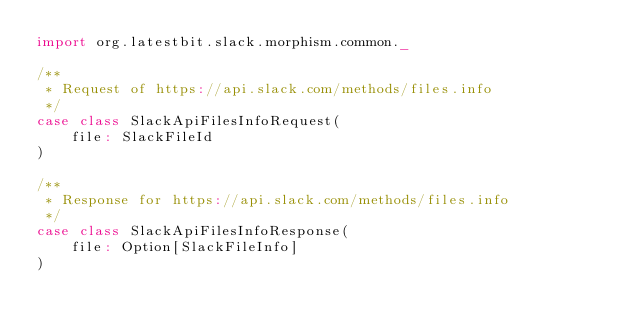<code> <loc_0><loc_0><loc_500><loc_500><_Scala_>import org.latestbit.slack.morphism.common._

/**
 * Request of https://api.slack.com/methods/files.info
 */
case class SlackApiFilesInfoRequest(
    file: SlackFileId
)

/**
 * Response for https://api.slack.com/methods/files.info
 */
case class SlackApiFilesInfoResponse(
    file: Option[SlackFileInfo]
)
</code> 